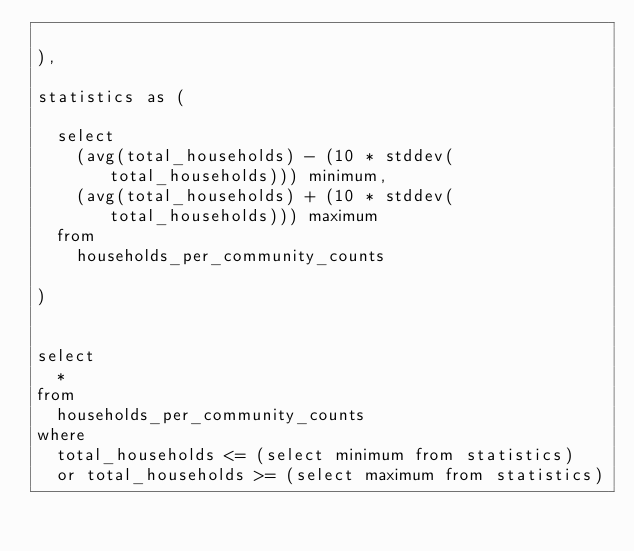Convert code to text. <code><loc_0><loc_0><loc_500><loc_500><_SQL_>
),

statistics as (

  select
    (avg(total_households) - (10 * stddev(total_households))) minimum,
    (avg(total_households) + (10 * stddev(total_households))) maximum
  from
    households_per_community_counts

)


select
  *
from
  households_per_community_counts
where
  total_households <= (select minimum from statistics)
  or total_households >= (select maximum from statistics)</code> 